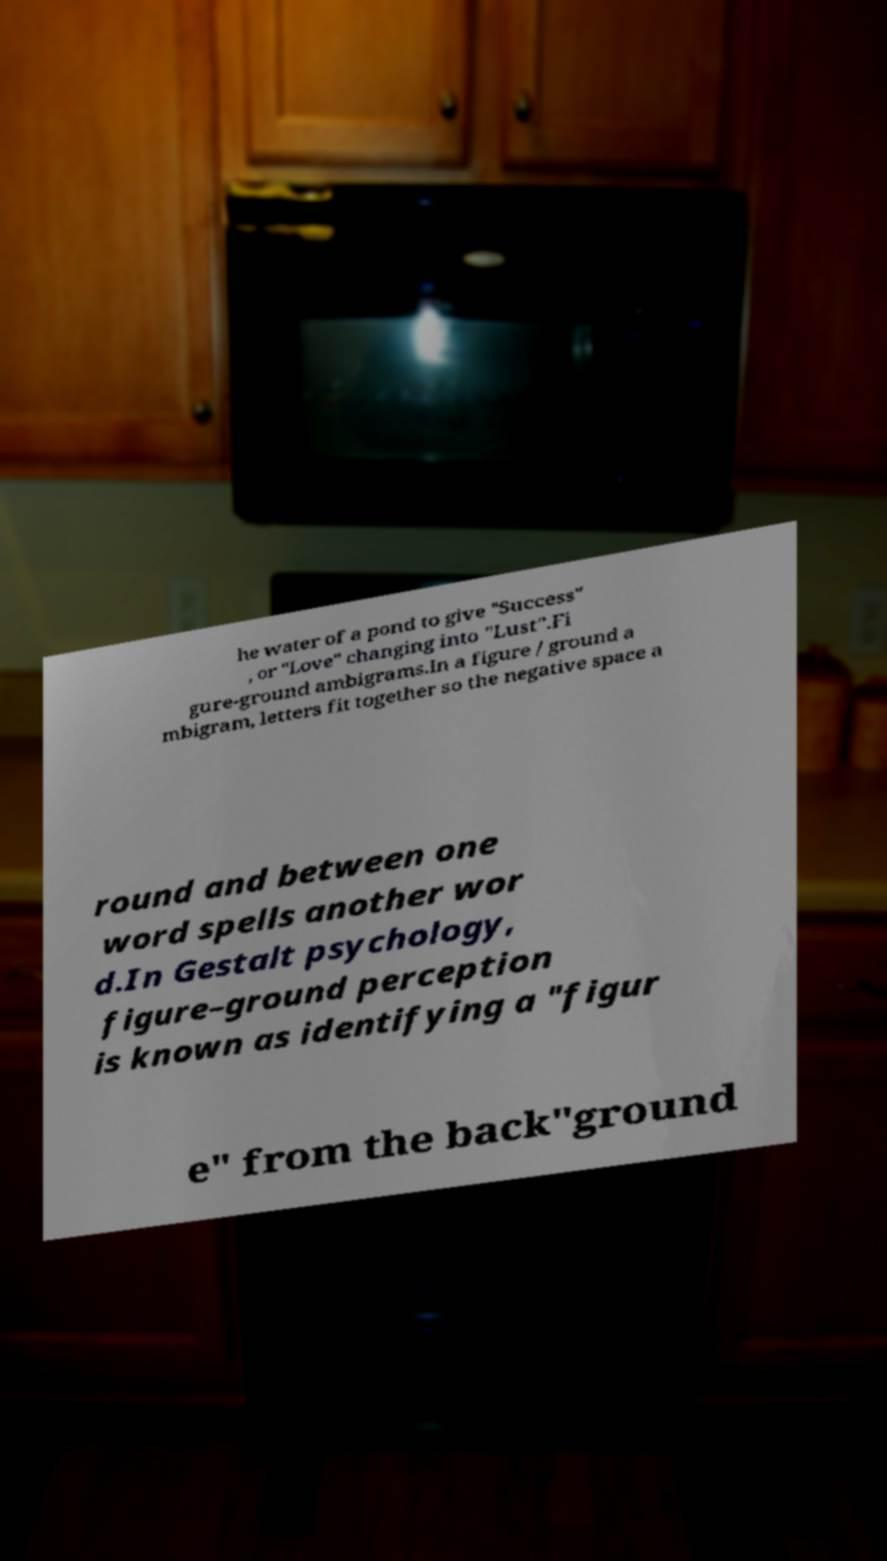I need the written content from this picture converted into text. Can you do that? he water of a pond to give "Success" , or "Love" changing into "Lust".Fi gure-ground ambigrams.In a figure / ground a mbigram, letters fit together so the negative space a round and between one word spells another wor d.In Gestalt psychology, figure–ground perception is known as identifying a "figur e" from the back"ground 